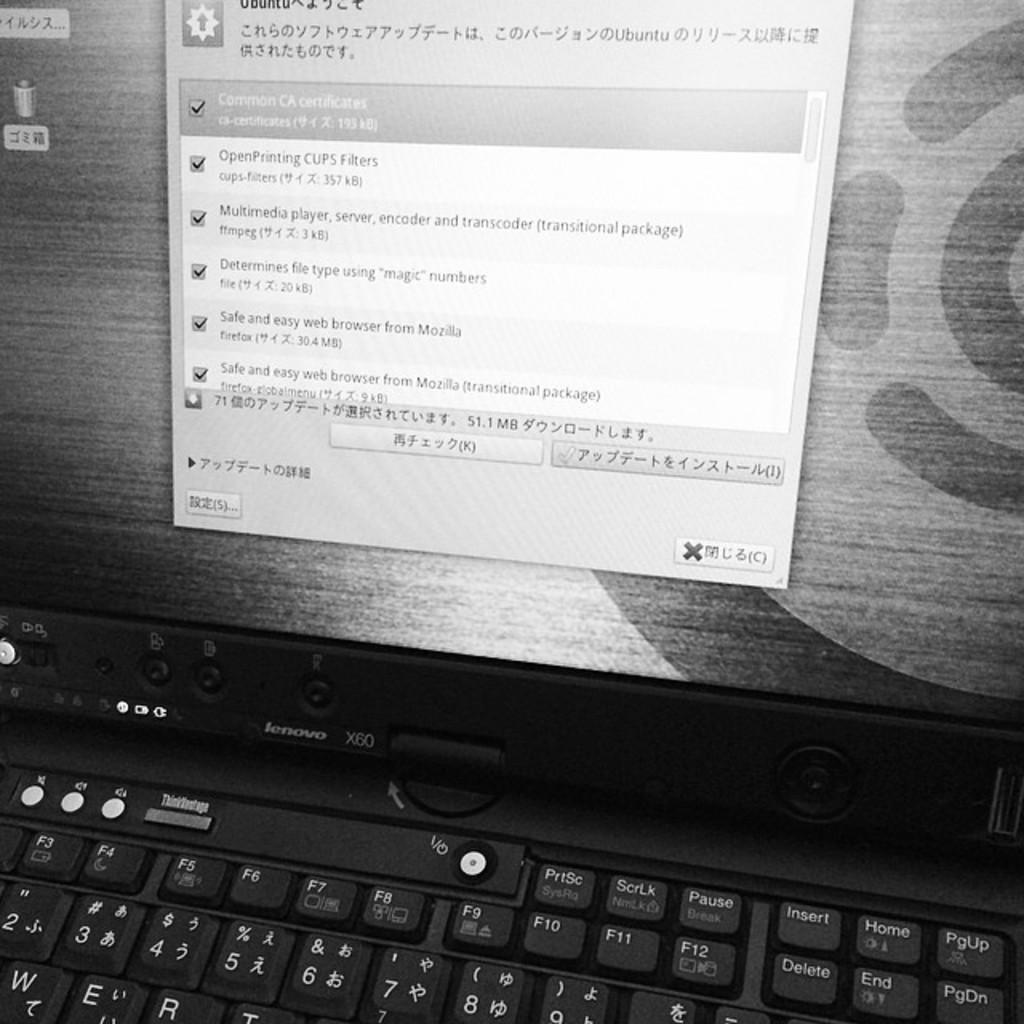<image>
Share a concise interpretation of the image provided. A Lenovo computer screen with a checklist in a window about printing, multimedia players, and web browsing. 